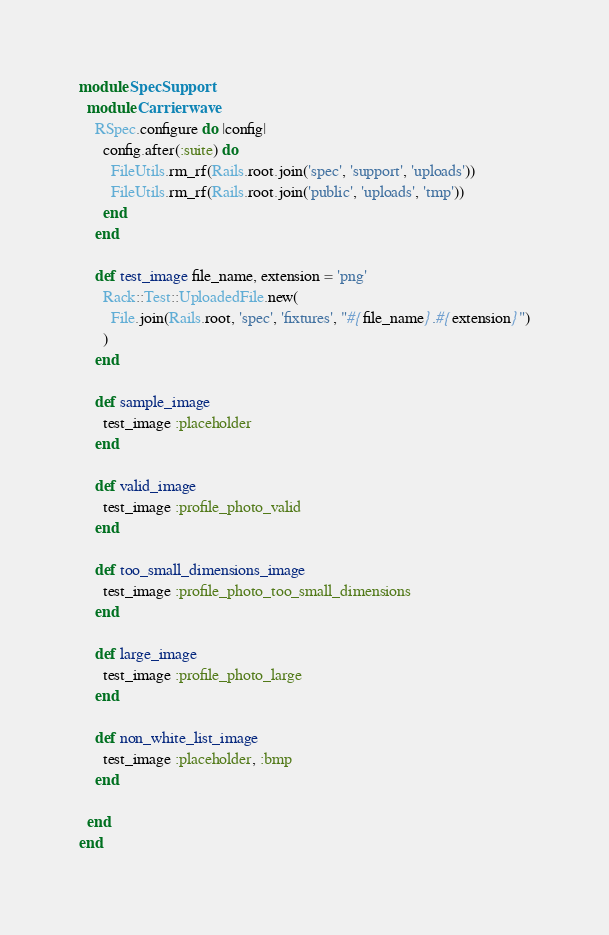<code> <loc_0><loc_0><loc_500><loc_500><_Ruby_>module SpecSupport
  module Carrierwave
    RSpec.configure do |config|
      config.after(:suite) do
        FileUtils.rm_rf(Rails.root.join('spec', 'support', 'uploads'))
        FileUtils.rm_rf(Rails.root.join('public', 'uploads', 'tmp'))
      end
    end

    def test_image file_name, extension = 'png'
      Rack::Test::UploadedFile.new(
        File.join(Rails.root, 'spec', 'fixtures', "#{file_name}.#{extension}")
      )
    end

    def sample_image
      test_image :placeholder
    end

    def valid_image
      test_image :profile_photo_valid
    end

    def too_small_dimensions_image
      test_image :profile_photo_too_small_dimensions
    end

    def large_image
      test_image :profile_photo_large
    end

    def non_white_list_image
      test_image :placeholder, :bmp
    end

  end
end
</code> 